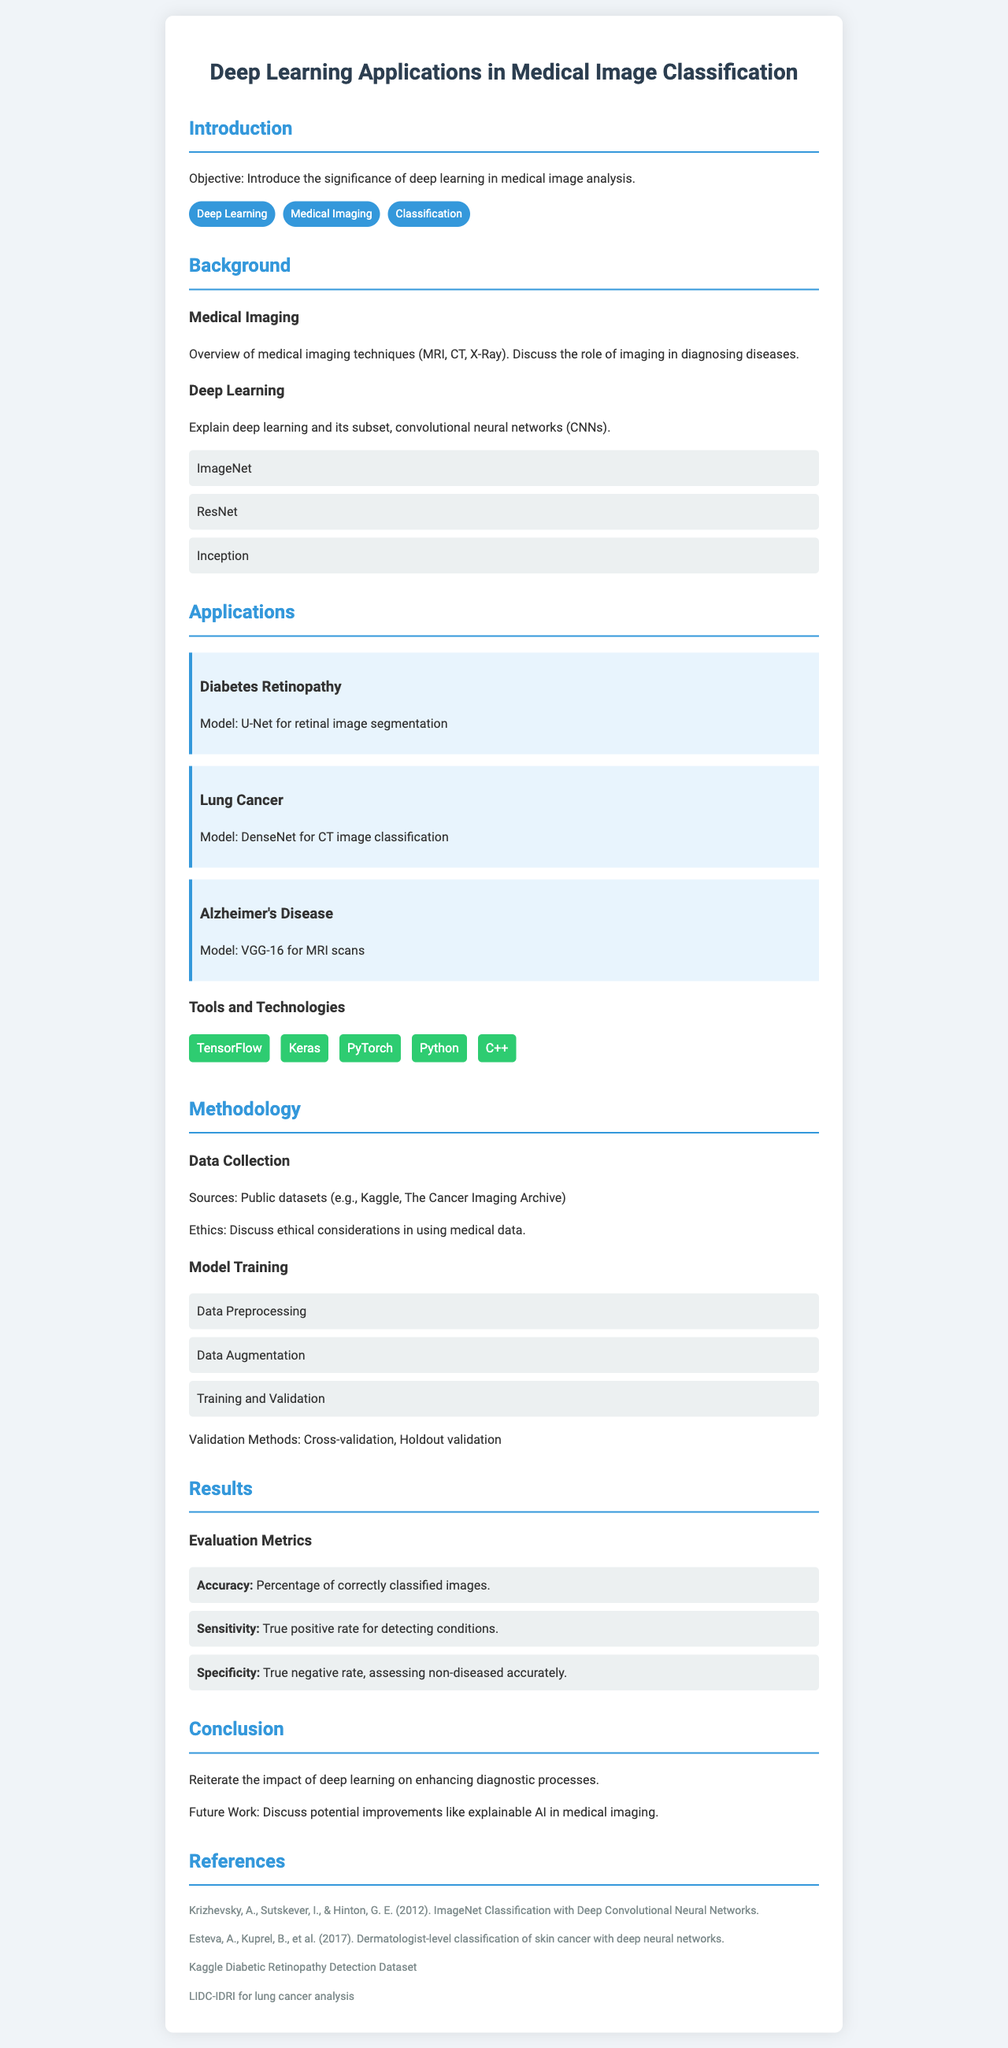What is the main objective of this presentation? The objective is to introduce the significance of deep learning in medical image analysis.
Answer: Introduce the significance of deep learning in medical image analysis Which medical imaging techniques are mentioned in the document? The document mentions MRI, CT, and X-Ray as medical imaging techniques.
Answer: MRI, CT, X-Ray What model is used for retinal image segmentation in diabetes retinopathy? The model specified for retinal image segmentation is U-Net.
Answer: U-Net Name one tool used in deep learning applications listed in the document. One of the tools mentioned for deep learning applications is TensorFlow.
Answer: TensorFlow What evaluation metric indicates the true positive rate for detecting conditions? The metric that indicates the true positive rate is Sensitivity.
Answer: Sensitivity How many applications are discussed in the document? The document discusses three applications: Diabetes Retinopathy, Lung Cancer, and Alzheimer's Disease.
Answer: Three What is the purpose of data preprocessing in the model training section? Data preprocessing is important for preparing data for model training.
Answer: Preparing data for model training What does the future work section suggest for medical imaging? The future work section suggests discussing potential improvements like explainable AI.
Answer: Explainable AI Which dataset is mentioned for lung cancer analysis? The dataset mentioned for lung cancer analysis is LIDC-IDRI.
Answer: LIDC-IDRI 